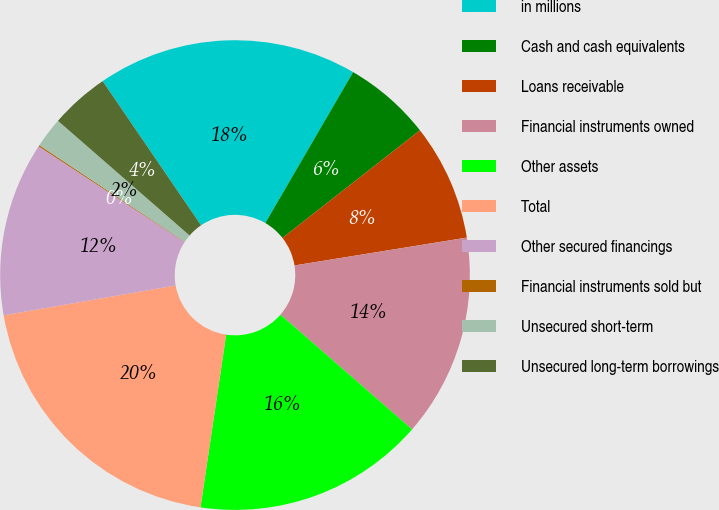<chart> <loc_0><loc_0><loc_500><loc_500><pie_chart><fcel>in millions<fcel>Cash and cash equivalents<fcel>Loans receivable<fcel>Financial instruments owned<fcel>Other assets<fcel>Total<fcel>Other secured financings<fcel>Financial instruments sold but<fcel>Unsecured short-term<fcel>Unsecured long-term borrowings<nl><fcel>17.92%<fcel>6.04%<fcel>8.02%<fcel>13.96%<fcel>15.94%<fcel>19.91%<fcel>11.98%<fcel>0.09%<fcel>2.08%<fcel>4.06%<nl></chart> 